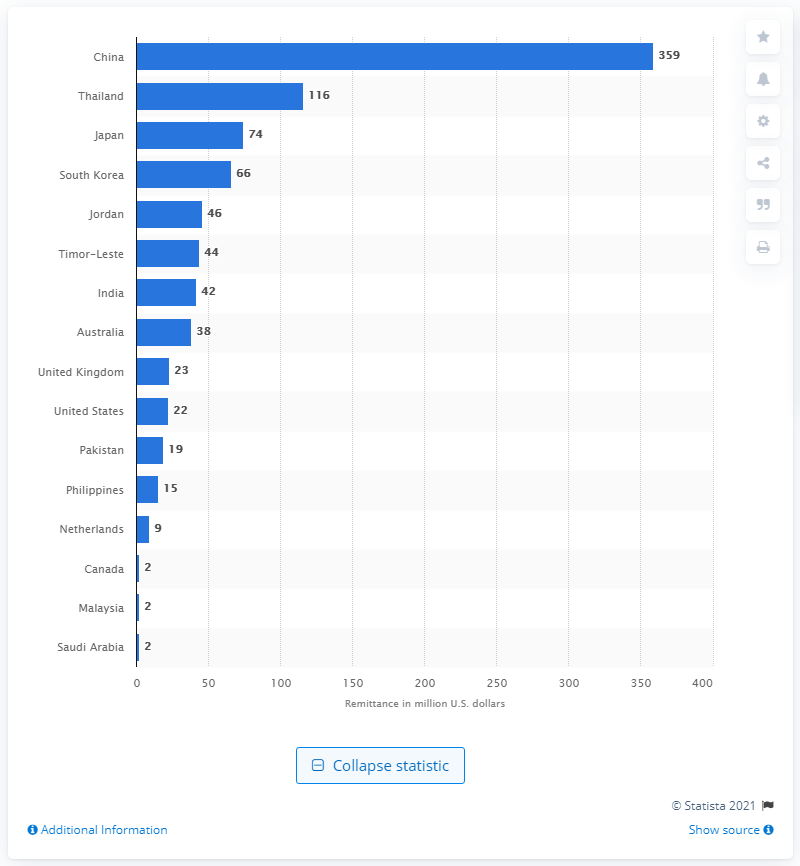Point out several critical features in this image. People in Indonesia transferred a total of $359 million to China in 2017. 